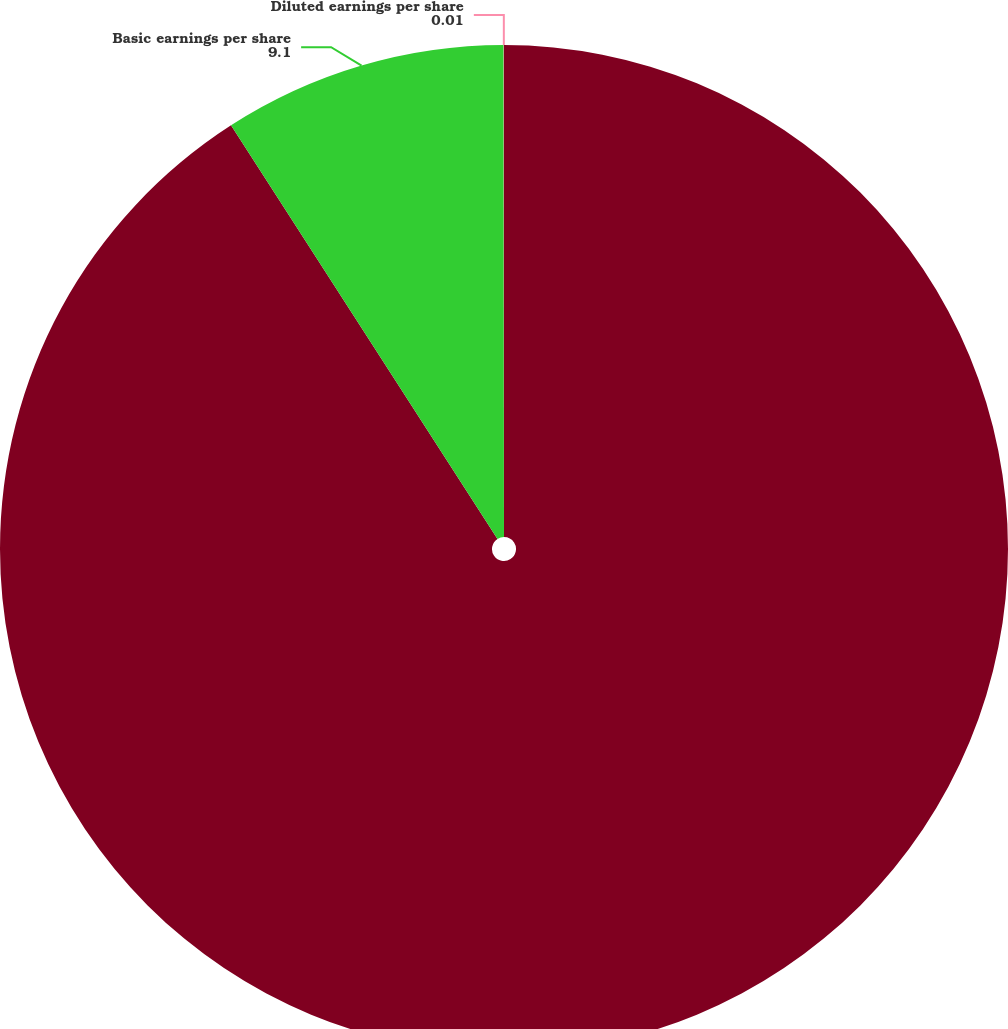<chart> <loc_0><loc_0><loc_500><loc_500><pie_chart><fcel>Revenues<fcel>Basic earnings per share<fcel>Diluted earnings per share<nl><fcel>90.89%<fcel>9.1%<fcel>0.01%<nl></chart> 